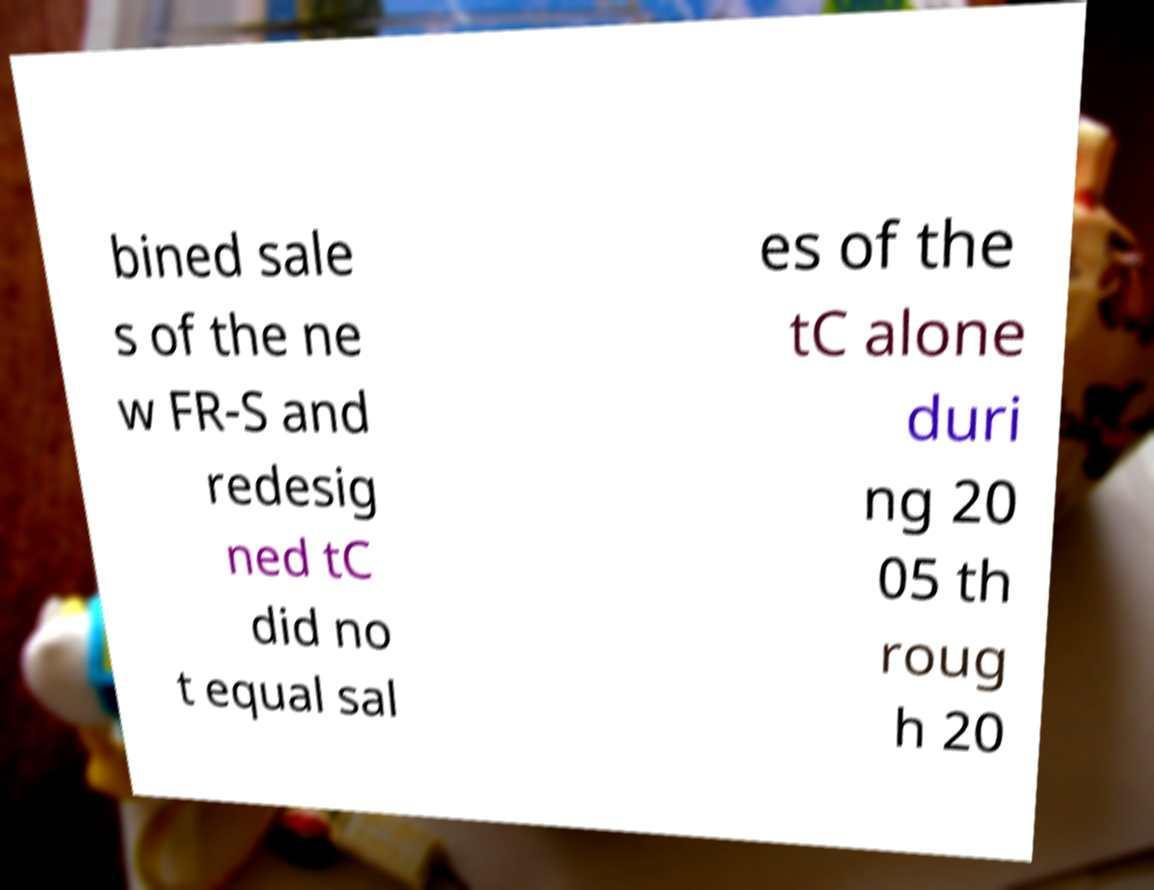Can you accurately transcribe the text from the provided image for me? bined sale s of the ne w FR-S and redesig ned tC did no t equal sal es of the tC alone duri ng 20 05 th roug h 20 